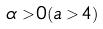<formula> <loc_0><loc_0><loc_500><loc_500>\alpha > 0 ( a > 4 )</formula> 